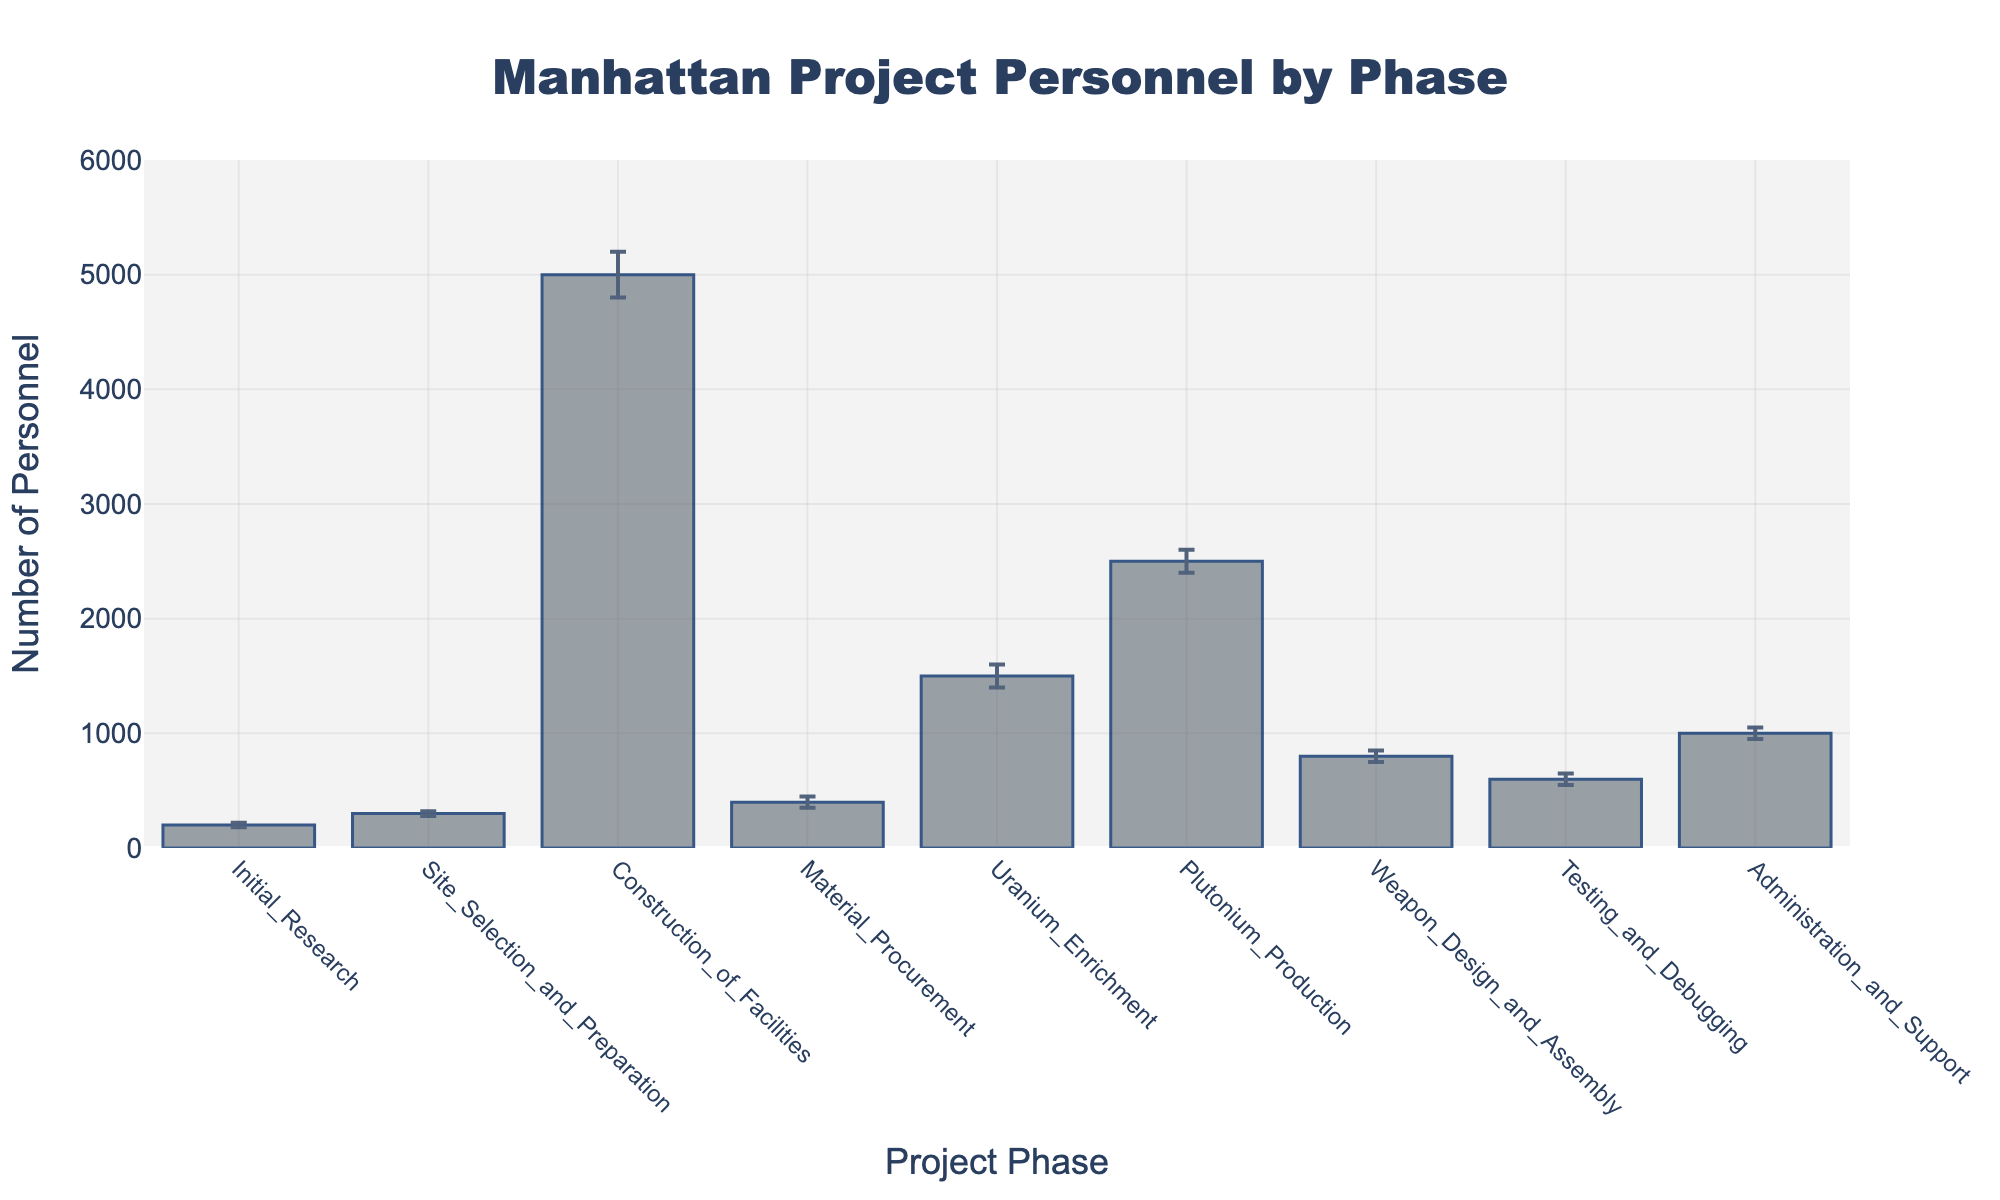What is the title of the bar chart? The title of the chart is displayed at the top and is typically the most prominent text. The title provides a summary of the data shown.
Answer: Manhattan Project Personnel by Phase Which phase had the highest number of personnel? To find the phase with the highest number of personnel, look for the tallest bar in the bar chart.
Answer: Construction of Facilities What is the range of personnel involved in the Initial Research phase? The range can be found by looking at the error bars above and below the bar for Initial Research.
Answer: 180 to 220 How does the number of personnel in Plutonium Production compare to Uranium Enrichment? Compare the heights of the bars for Plutonium Production and Uranium Enrichment, noting that Plutonium Production is higher.
Answer: Plutonium Production has more personnel What is the total number of personnel across all phases? Add up the number of personnel for each phase: 200 + 300 + 5000 + 400 + 1500 + 2500 + 800 + 600 + 1000 = 12300.
Answer: 12300 Which phases have a personnel number close to 1000? Look for bars that are around the 1000-mark and check the error bars for overlap with this value. Both Uranium Enrichment and Administration and Support are close to 1000.
Answer: Uranium Enrichment, Administration and Support What is the uncertainty range (upper minus lower bound) for Material Procurement? The uncertainty range is the difference between the upper and lower error bounds: 450 - 350 = 100.
Answer: 100 Which phase has the smallest uncertainty range? Compare the lengths of the error bars for each phase. The smallest uncertainty range will be the shortest error bar.
Answer: Site Selection and Preparation What is the average number of personnel for the phases Initial Research, Material Procurement, and Testing and Debugging? Calculate the average by adding the number of personnel for these three phases and then divide by 3: (200 + 400 + 600) / 3 = 400.
Answer: 400 In which phase is the error bar with the smallest upper bound found? Look for the bar with the smallest upper bound by examining the top of the error bars. Initial Research has the smallest upper bound, which is 220.
Answer: Initial Research 